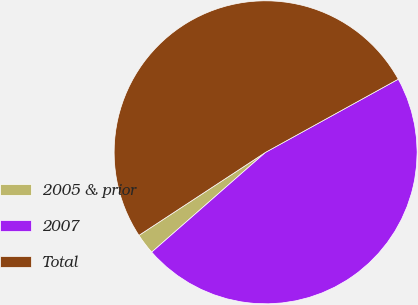Convert chart. <chart><loc_0><loc_0><loc_500><loc_500><pie_chart><fcel>2005 & prior<fcel>2007<fcel>Total<nl><fcel>2.22%<fcel>46.56%<fcel>51.22%<nl></chart> 